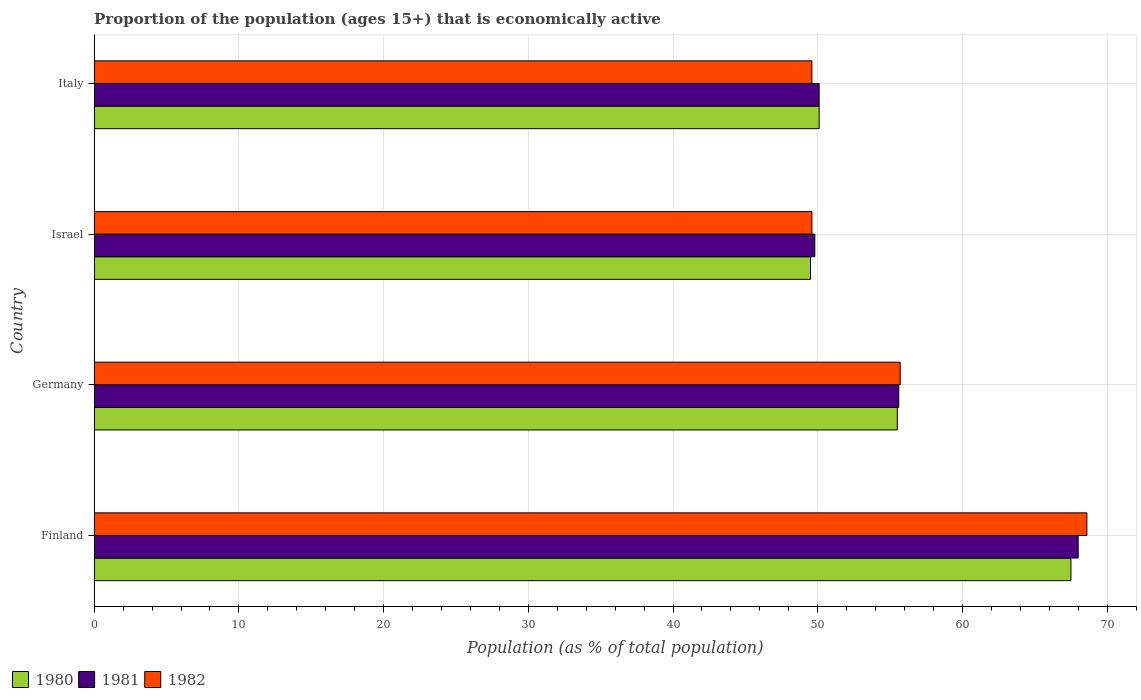How many bars are there on the 4th tick from the bottom?
Your answer should be very brief. 3. What is the label of the 3rd group of bars from the top?
Provide a short and direct response. Germany. What is the proportion of the population that is economically active in 1981 in Italy?
Provide a succinct answer. 50.1. Across all countries, what is the maximum proportion of the population that is economically active in 1982?
Your answer should be compact. 68.6. Across all countries, what is the minimum proportion of the population that is economically active in 1980?
Offer a terse response. 49.5. In which country was the proportion of the population that is economically active in 1980 maximum?
Your answer should be very brief. Finland. In which country was the proportion of the population that is economically active in 1980 minimum?
Your answer should be very brief. Israel. What is the total proportion of the population that is economically active in 1982 in the graph?
Give a very brief answer. 223.5. What is the difference between the proportion of the population that is economically active in 1982 in Germany and that in Italy?
Give a very brief answer. 6.1. What is the difference between the proportion of the population that is economically active in 1981 in Italy and the proportion of the population that is economically active in 1980 in Finland?
Offer a terse response. -17.4. What is the average proportion of the population that is economically active in 1980 per country?
Make the answer very short. 55.65. What is the difference between the proportion of the population that is economically active in 1981 and proportion of the population that is economically active in 1982 in Finland?
Give a very brief answer. -0.6. What is the ratio of the proportion of the population that is economically active in 1980 in Finland to that in Italy?
Keep it short and to the point. 1.35. Is the proportion of the population that is economically active in 1980 in Finland less than that in Israel?
Offer a terse response. No. What is the difference between the highest and the lowest proportion of the population that is economically active in 1981?
Your answer should be very brief. 18.2. Is the sum of the proportion of the population that is economically active in 1980 in Finland and Italy greater than the maximum proportion of the population that is economically active in 1982 across all countries?
Make the answer very short. Yes. What does the 2nd bar from the top in Israel represents?
Give a very brief answer. 1981. What does the 2nd bar from the bottom in Italy represents?
Offer a terse response. 1981. Is it the case that in every country, the sum of the proportion of the population that is economically active in 1981 and proportion of the population that is economically active in 1982 is greater than the proportion of the population that is economically active in 1980?
Ensure brevity in your answer.  Yes. Are all the bars in the graph horizontal?
Give a very brief answer. Yes. How many countries are there in the graph?
Make the answer very short. 4. What is the difference between two consecutive major ticks on the X-axis?
Give a very brief answer. 10. Are the values on the major ticks of X-axis written in scientific E-notation?
Your answer should be compact. No. Does the graph contain any zero values?
Ensure brevity in your answer.  No. Where does the legend appear in the graph?
Ensure brevity in your answer.  Bottom left. How many legend labels are there?
Your answer should be compact. 3. How are the legend labels stacked?
Your response must be concise. Horizontal. What is the title of the graph?
Make the answer very short. Proportion of the population (ages 15+) that is economically active. Does "2009" appear as one of the legend labels in the graph?
Offer a terse response. No. What is the label or title of the X-axis?
Give a very brief answer. Population (as % of total population). What is the Population (as % of total population) in 1980 in Finland?
Offer a terse response. 67.5. What is the Population (as % of total population) in 1982 in Finland?
Ensure brevity in your answer.  68.6. What is the Population (as % of total population) in 1980 in Germany?
Provide a succinct answer. 55.5. What is the Population (as % of total population) in 1981 in Germany?
Your answer should be compact. 55.6. What is the Population (as % of total population) in 1982 in Germany?
Ensure brevity in your answer.  55.7. What is the Population (as % of total population) in 1980 in Israel?
Offer a very short reply. 49.5. What is the Population (as % of total population) in 1981 in Israel?
Your answer should be compact. 49.8. What is the Population (as % of total population) in 1982 in Israel?
Keep it short and to the point. 49.6. What is the Population (as % of total population) in 1980 in Italy?
Provide a succinct answer. 50.1. What is the Population (as % of total population) in 1981 in Italy?
Your response must be concise. 50.1. What is the Population (as % of total population) in 1982 in Italy?
Your response must be concise. 49.6. Across all countries, what is the maximum Population (as % of total population) in 1980?
Keep it short and to the point. 67.5. Across all countries, what is the maximum Population (as % of total population) of 1982?
Your answer should be compact. 68.6. Across all countries, what is the minimum Population (as % of total population) in 1980?
Your response must be concise. 49.5. Across all countries, what is the minimum Population (as % of total population) of 1981?
Provide a succinct answer. 49.8. Across all countries, what is the minimum Population (as % of total population) in 1982?
Give a very brief answer. 49.6. What is the total Population (as % of total population) in 1980 in the graph?
Ensure brevity in your answer.  222.6. What is the total Population (as % of total population) of 1981 in the graph?
Make the answer very short. 223.5. What is the total Population (as % of total population) in 1982 in the graph?
Make the answer very short. 223.5. What is the difference between the Population (as % of total population) of 1981 in Finland and that in Germany?
Provide a succinct answer. 12.4. What is the difference between the Population (as % of total population) in 1982 in Finland and that in Germany?
Provide a succinct answer. 12.9. What is the difference between the Population (as % of total population) in 1982 in Finland and that in Israel?
Your response must be concise. 19. What is the difference between the Population (as % of total population) in 1981 in Finland and that in Italy?
Provide a short and direct response. 17.9. What is the difference between the Population (as % of total population) of 1980 in Germany and that in Israel?
Offer a terse response. 6. What is the difference between the Population (as % of total population) in 1982 in Germany and that in Israel?
Ensure brevity in your answer.  6.1. What is the difference between the Population (as % of total population) of 1980 in Germany and that in Italy?
Give a very brief answer. 5.4. What is the difference between the Population (as % of total population) of 1981 in Germany and that in Italy?
Offer a very short reply. 5.5. What is the difference between the Population (as % of total population) of 1981 in Israel and that in Italy?
Ensure brevity in your answer.  -0.3. What is the difference between the Population (as % of total population) in 1980 in Finland and the Population (as % of total population) in 1981 in Germany?
Offer a terse response. 11.9. What is the difference between the Population (as % of total population) in 1980 in Finland and the Population (as % of total population) in 1982 in Germany?
Your response must be concise. 11.8. What is the difference between the Population (as % of total population) of 1980 in Finland and the Population (as % of total population) of 1981 in Israel?
Ensure brevity in your answer.  17.7. What is the difference between the Population (as % of total population) of 1980 in Finland and the Population (as % of total population) of 1982 in Israel?
Offer a very short reply. 17.9. What is the difference between the Population (as % of total population) in 1981 in Finland and the Population (as % of total population) in 1982 in Israel?
Provide a succinct answer. 18.4. What is the difference between the Population (as % of total population) of 1980 in Finland and the Population (as % of total population) of 1981 in Italy?
Your response must be concise. 17.4. What is the difference between the Population (as % of total population) of 1981 in Finland and the Population (as % of total population) of 1982 in Italy?
Ensure brevity in your answer.  18.4. What is the difference between the Population (as % of total population) of 1980 in Germany and the Population (as % of total population) of 1982 in Israel?
Give a very brief answer. 5.9. What is the difference between the Population (as % of total population) in 1981 in Germany and the Population (as % of total population) in 1982 in Israel?
Ensure brevity in your answer.  6. What is the difference between the Population (as % of total population) in 1980 in Germany and the Population (as % of total population) in 1982 in Italy?
Ensure brevity in your answer.  5.9. What is the difference between the Population (as % of total population) of 1981 in Germany and the Population (as % of total population) of 1982 in Italy?
Your answer should be compact. 6. What is the difference between the Population (as % of total population) of 1981 in Israel and the Population (as % of total population) of 1982 in Italy?
Provide a short and direct response. 0.2. What is the average Population (as % of total population) in 1980 per country?
Make the answer very short. 55.65. What is the average Population (as % of total population) in 1981 per country?
Provide a short and direct response. 55.88. What is the average Population (as % of total population) in 1982 per country?
Provide a succinct answer. 55.88. What is the difference between the Population (as % of total population) in 1980 and Population (as % of total population) in 1982 in Finland?
Make the answer very short. -1.1. What is the difference between the Population (as % of total population) of 1981 and Population (as % of total population) of 1982 in Finland?
Give a very brief answer. -0.6. What is the difference between the Population (as % of total population) in 1980 and Population (as % of total population) in 1981 in Germany?
Offer a very short reply. -0.1. What is the difference between the Population (as % of total population) of 1980 and Population (as % of total population) of 1982 in Germany?
Keep it short and to the point. -0.2. What is the difference between the Population (as % of total population) of 1980 and Population (as % of total population) of 1981 in Israel?
Provide a succinct answer. -0.3. What is the difference between the Population (as % of total population) of 1980 and Population (as % of total population) of 1982 in Israel?
Provide a succinct answer. -0.1. What is the difference between the Population (as % of total population) in 1981 and Population (as % of total population) in 1982 in Israel?
Provide a succinct answer. 0.2. What is the difference between the Population (as % of total population) in 1980 and Population (as % of total population) in 1982 in Italy?
Provide a short and direct response. 0.5. What is the ratio of the Population (as % of total population) of 1980 in Finland to that in Germany?
Your answer should be very brief. 1.22. What is the ratio of the Population (as % of total population) of 1981 in Finland to that in Germany?
Offer a terse response. 1.22. What is the ratio of the Population (as % of total population) of 1982 in Finland to that in Germany?
Keep it short and to the point. 1.23. What is the ratio of the Population (as % of total population) in 1980 in Finland to that in Israel?
Your answer should be compact. 1.36. What is the ratio of the Population (as % of total population) in 1981 in Finland to that in Israel?
Make the answer very short. 1.37. What is the ratio of the Population (as % of total population) of 1982 in Finland to that in Israel?
Offer a terse response. 1.38. What is the ratio of the Population (as % of total population) in 1980 in Finland to that in Italy?
Your answer should be very brief. 1.35. What is the ratio of the Population (as % of total population) of 1981 in Finland to that in Italy?
Provide a succinct answer. 1.36. What is the ratio of the Population (as % of total population) of 1982 in Finland to that in Italy?
Keep it short and to the point. 1.38. What is the ratio of the Population (as % of total population) of 1980 in Germany to that in Israel?
Ensure brevity in your answer.  1.12. What is the ratio of the Population (as % of total population) in 1981 in Germany to that in Israel?
Make the answer very short. 1.12. What is the ratio of the Population (as % of total population) in 1982 in Germany to that in Israel?
Your response must be concise. 1.12. What is the ratio of the Population (as % of total population) in 1980 in Germany to that in Italy?
Make the answer very short. 1.11. What is the ratio of the Population (as % of total population) in 1981 in Germany to that in Italy?
Your response must be concise. 1.11. What is the ratio of the Population (as % of total population) in 1982 in Germany to that in Italy?
Provide a succinct answer. 1.12. What is the ratio of the Population (as % of total population) in 1980 in Israel to that in Italy?
Make the answer very short. 0.99. What is the ratio of the Population (as % of total population) in 1981 in Israel to that in Italy?
Provide a short and direct response. 0.99. What is the difference between the highest and the second highest Population (as % of total population) of 1982?
Keep it short and to the point. 12.9. What is the difference between the highest and the lowest Population (as % of total population) in 1980?
Your response must be concise. 18. What is the difference between the highest and the lowest Population (as % of total population) in 1982?
Ensure brevity in your answer.  19. 